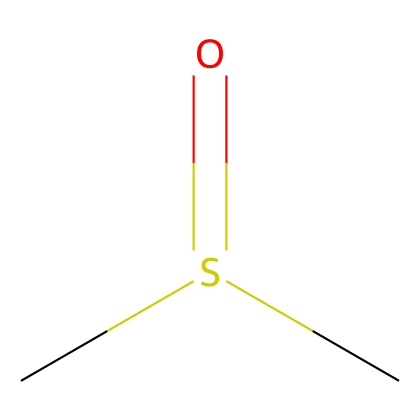How many carbon atoms are present in this compound? By examining the SMILES representation (CS(=O)C), we can see there are two 'C' symbols, indicating two carbon atoms.
Answer: 2 What functional group is present in dimethyl sulfoxide? The structure includes a sulfur atom bonded to an oxygen atom (S(=O)), indicating the presence of a sulfoxide functional group.
Answer: sulfoxide What is the total number of atoms in dimethyl sulfoxide? The SMILES representation (CS(=O)C) includes two carbon atoms (C), one sulfur atom (S), and one oxygen atom (O), which totals to four atoms (2+1+1=4).
Answer: 4 How many hydrogen atoms are attached to this compound? Considering the two carbon atoms and their bonding (both have three hydrogen atoms to satisfy the tetravalency), there are a total of six hydrogen atoms attached (3 for each C).
Answer: 6 What type of bonding is represented by S(=O)? The 'S(=O)' indicates a double bond between sulfur and oxygen, characterizing a double bond typical of sulfoxides.
Answer: double bond Which type of chemical does dimethyl sulfoxide belong to? This compound contains a sulfur atom and has specific structural features typical of sulfur compounds, categorizing it as a sulfur compound.
Answer: sulfur compound 